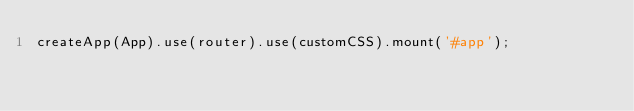Convert code to text. <code><loc_0><loc_0><loc_500><loc_500><_TypeScript_>createApp(App).use(router).use(customCSS).mount('#app');
</code> 